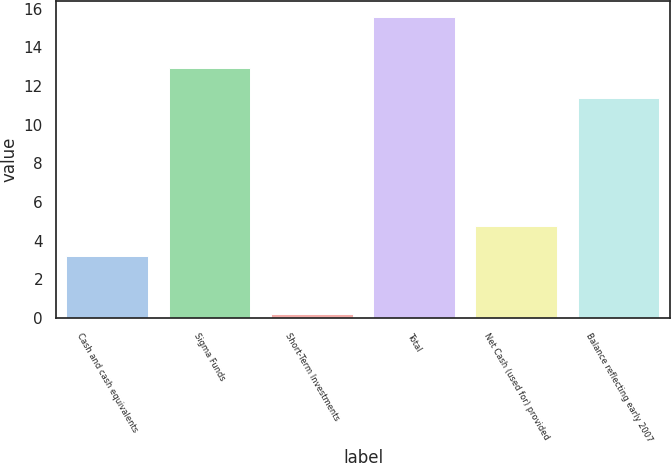Convert chart to OTSL. <chart><loc_0><loc_0><loc_500><loc_500><bar_chart><fcel>Cash and cash equivalents<fcel>Sigma Funds<fcel>Short-Term Investments<fcel>Total<fcel>Net Cash (used for) provided<fcel>Balance reflecting early 2007<nl><fcel>3.2<fcel>12.94<fcel>0.2<fcel>15.6<fcel>4.74<fcel>11.4<nl></chart> 